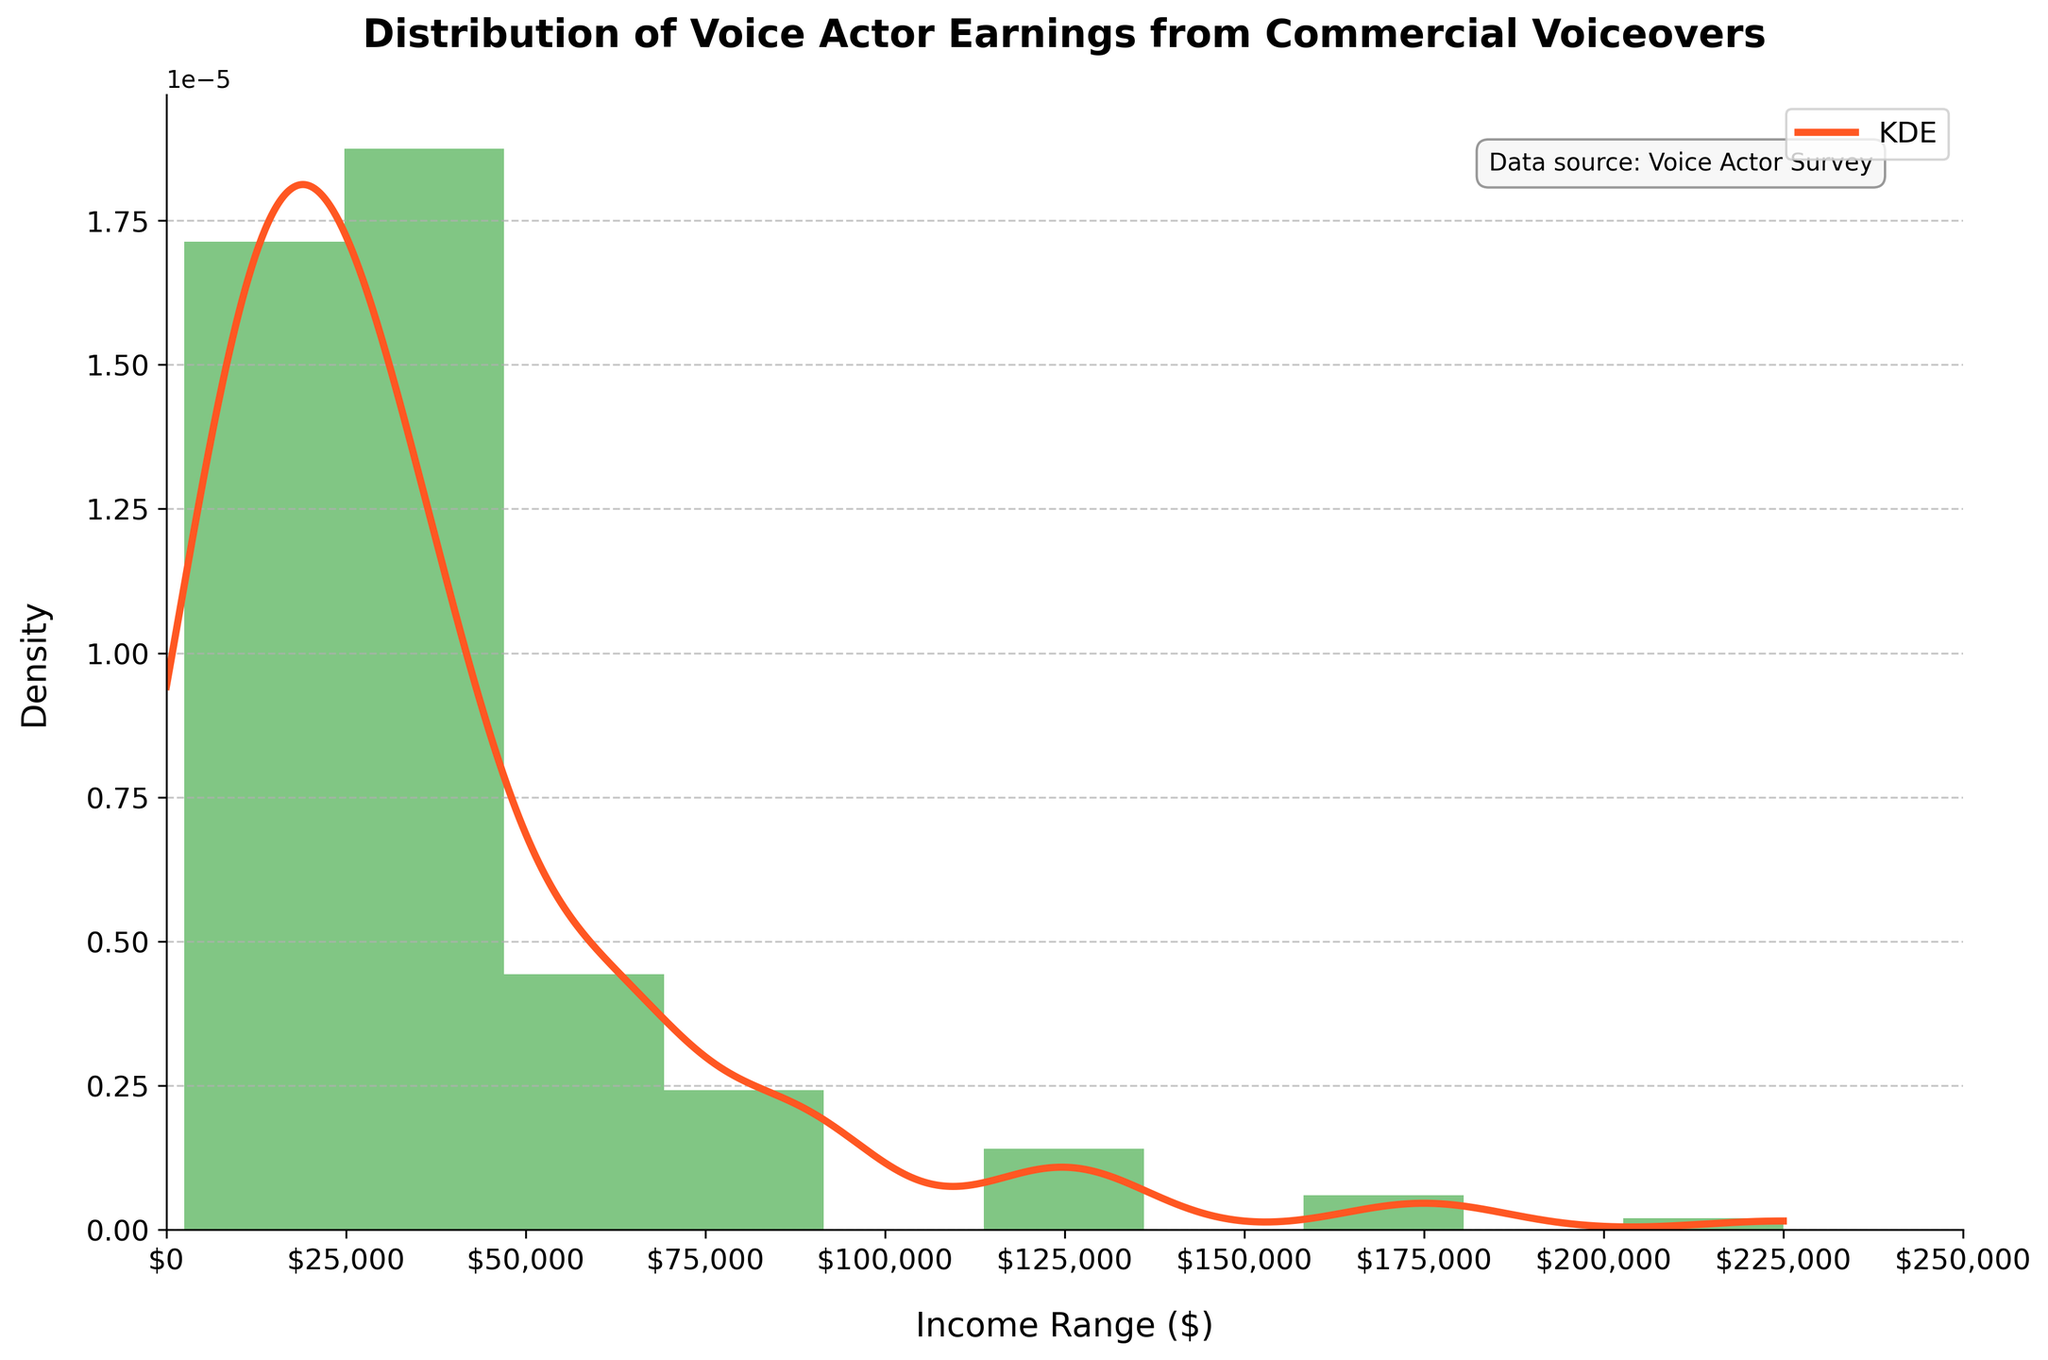What's the title of the plot? The title of the plot is written at the top center of the figure.
Answer: Distribution of Voice Actor Earnings from Commercial Voiceovers What is the range for the x-axis? The x-axis represents the income range in dollars and spans from 0 to 250,000.
Answer: 0 to 250,000 What does the y-axis represent? The y-axis represents the density of voice actor earnings in the corresponding income ranges.
Answer: Density Which income range has the highest frequency? The histogram shows the tallest bar, indicating the income range with the highest frequency.
Answer: 20,001-30,000 What is the main color used for the histogram bars? The histogram bars are mainly shown using a specific shade of green.
Answer: Green How does the KDE line differ in color from the histogram bars? The KDE line is a smooth curve shown using a different color from the histogram bars to distinguish between the two.
Answer: The KDE line is orange Is the density higher at the lower or upper end of the income range? By observing the height of the bars and the KDE line, we can determine whether the density is higher at the lower or upper end.
Answer: Lower end At approximately what income does the KDE curve peak? The peak of the KDE curve indicates the income range where the density is highest.
Answer: Around 25,000 What is the approximate median income based on the histogram? To find the median income, we look for the mid-point of the distribution where half of the earnings fall below and half above.
Answer: The median income is approximately around the 20,001-30,000 range Compare the frequency of voice actors earning between 50,001-75,000 and those earning between 10,001-20,000. Compare the height of the bars that represent these two income ranges to determine which is higher.
Answer: The 10,001-20,000 range has a higher frequency What is one key insight you can derive from the KDE curve about the distribution of voice actor earnings? The shape of the KDE curve helps understand the distribution pattern of earnings; where it peaks and where it tails off, showing the common and rare income ranges.
Answer: Earnings are more common in the lower income ranges and decrease as income increases 